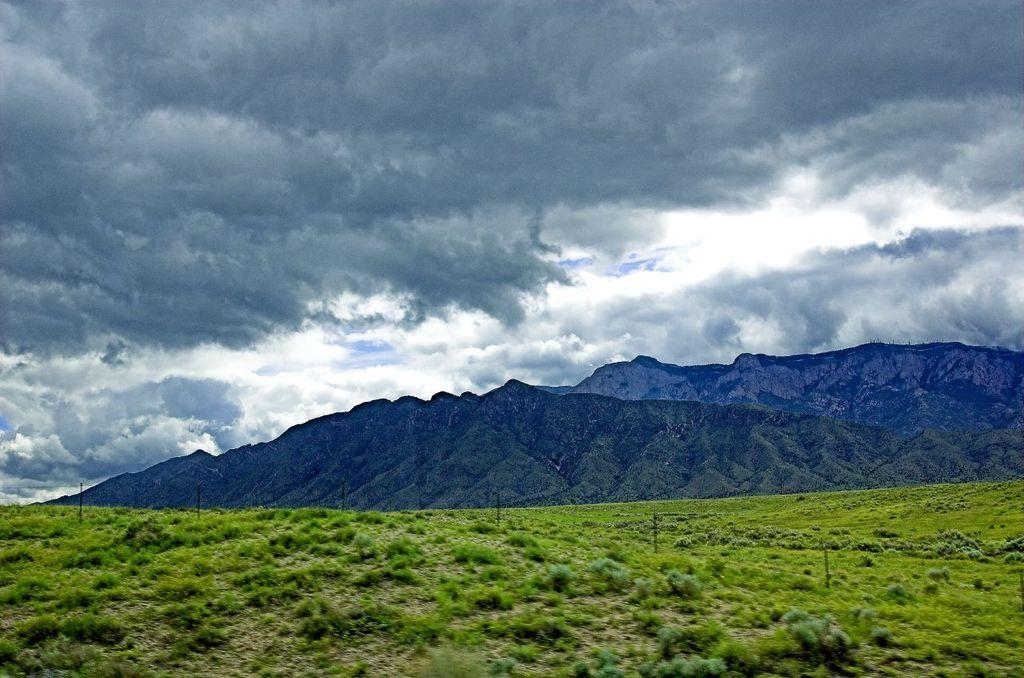What type of surface is visible in the image? There is a grassy surface in the image. What can be seen in the distance behind the grassy surface? There are mountains in the background of the image. What is visible at the top of the image? The sky is visible at the top of the image. How would you describe the sky in the image? The sky appears to be cloudy. How many thumbs can be seen on the grassy surface in the image? There are no thumbs visible on the grassy surface in the image. 